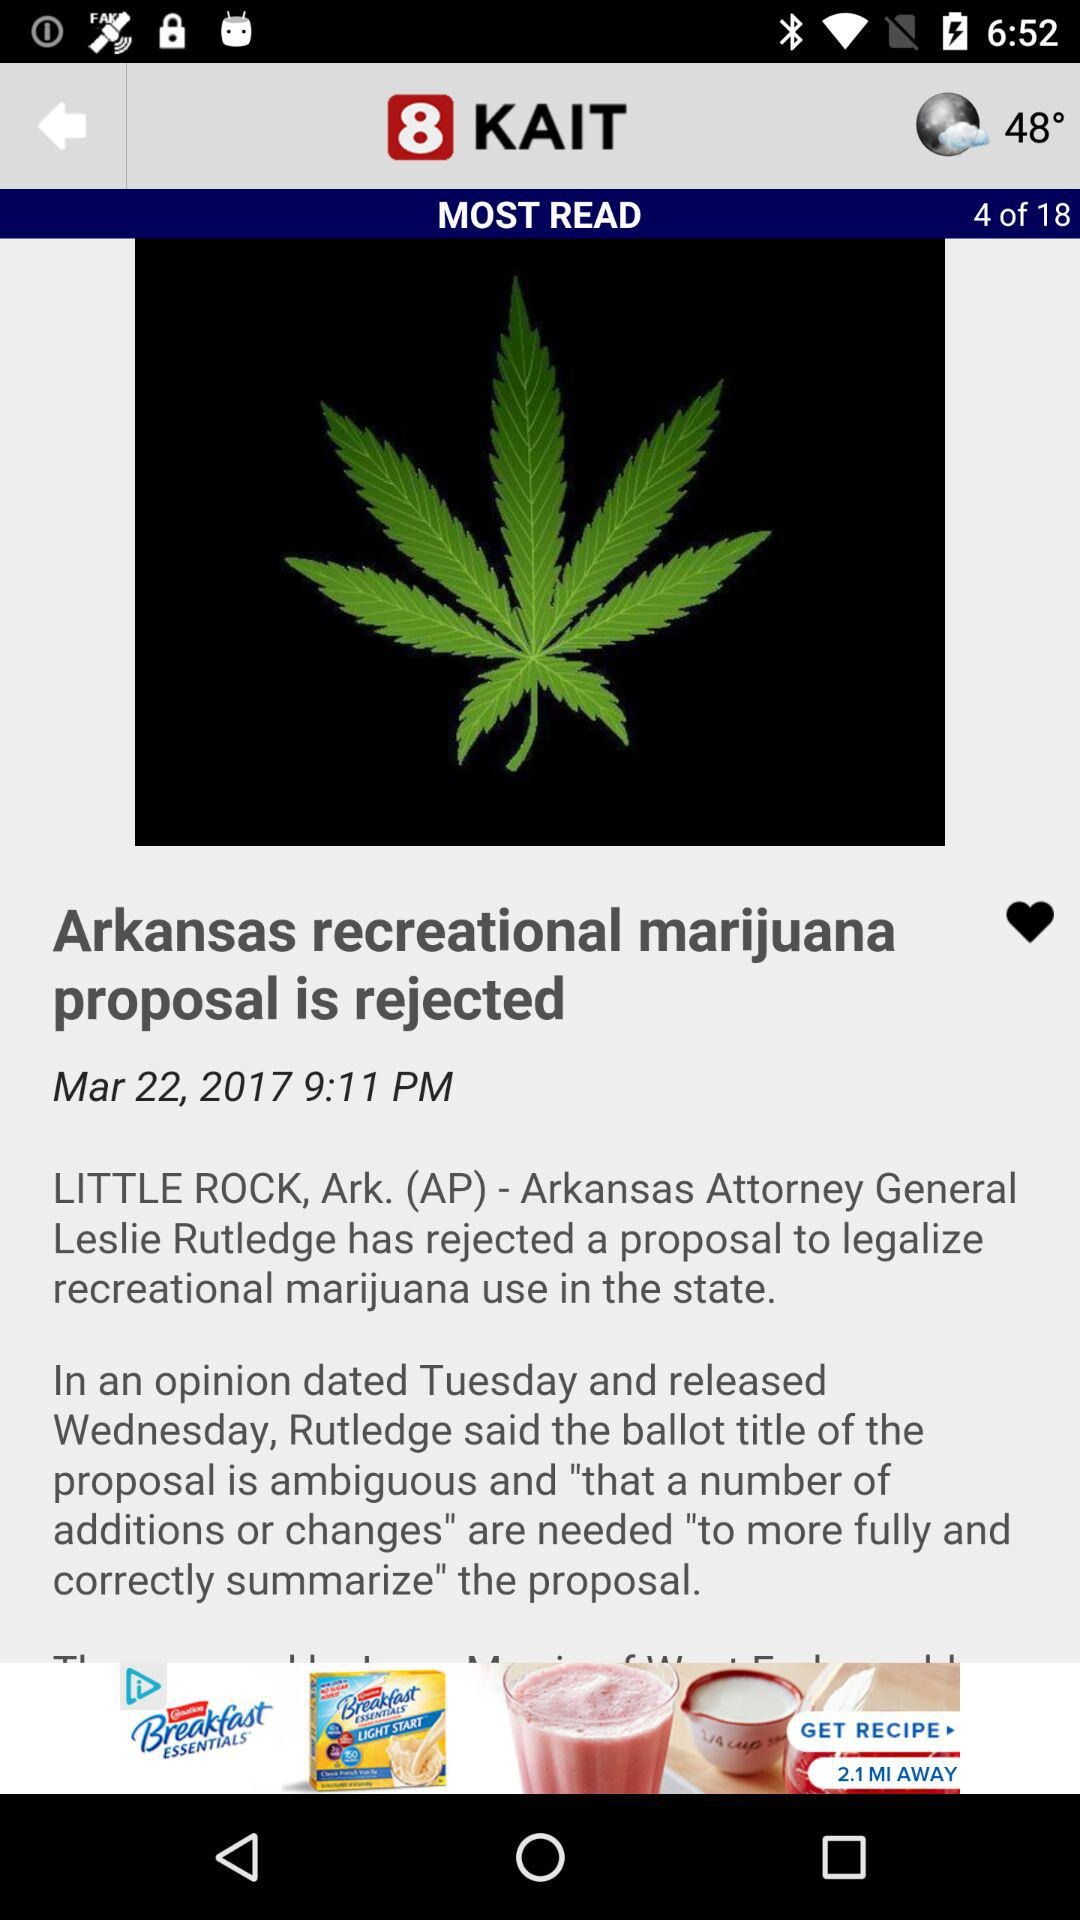How many pages are there in this article? There are 18 pages. 